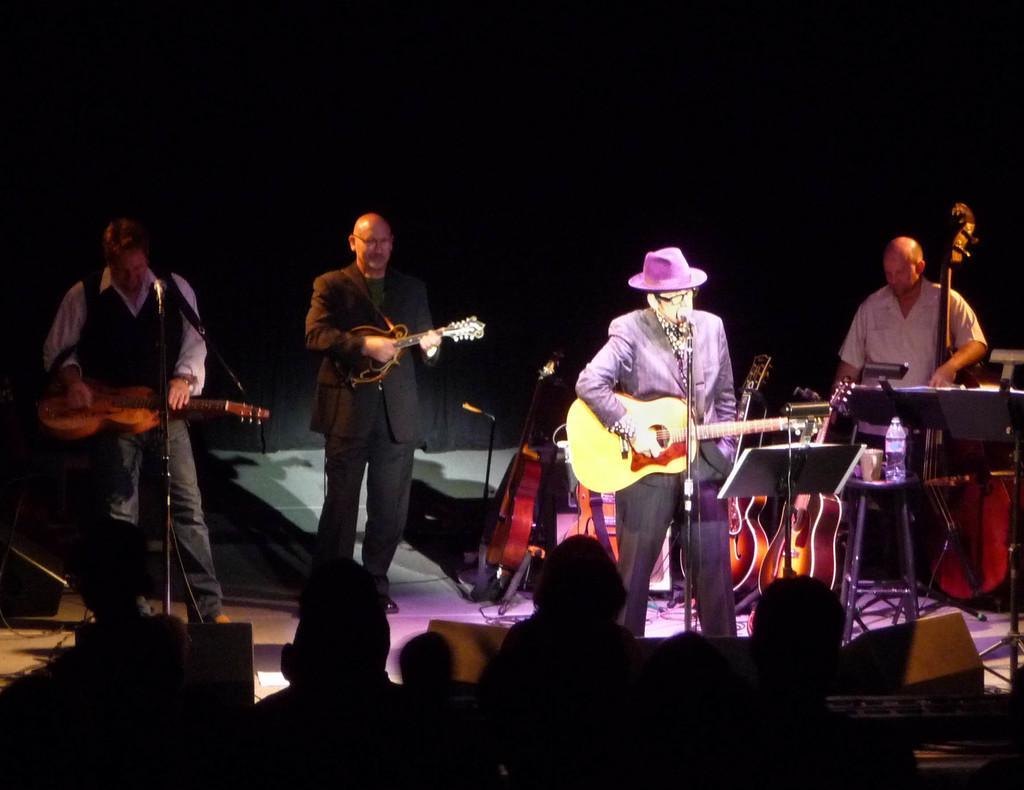In one or two sentences, can you explain what this image depicts? In this image i can see four man standing and playing musical instrument at the background i can see a curtain. 